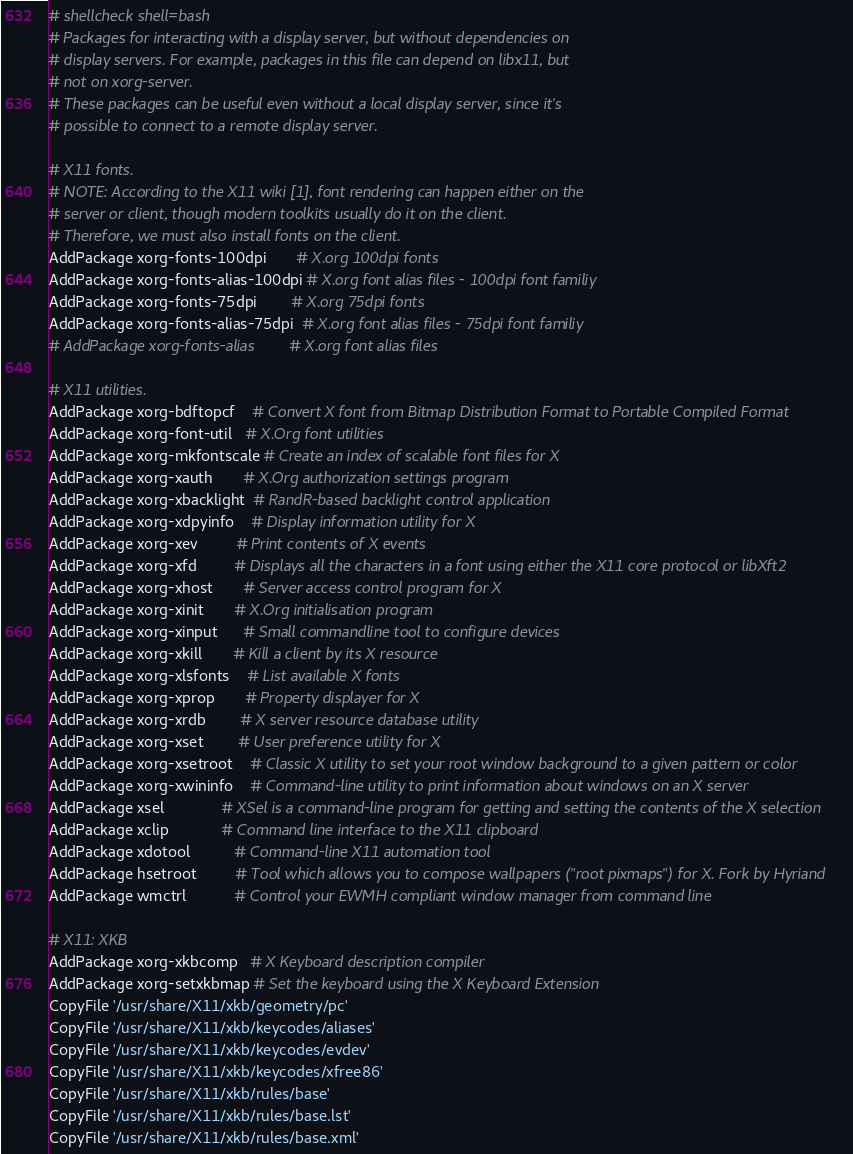Convert code to text. <code><loc_0><loc_0><loc_500><loc_500><_Bash_># shellcheck shell=bash
# Packages for interacting with a display server, but without dependencies on
# display servers. For example, packages in this file can depend on libx11, but
# not on xorg-server.
# These packages can be useful even without a local display server, since it's
# possible to connect to a remote display server.

# X11 fonts.
# NOTE: According to the X11 wiki [1], font rendering can happen either on the
# server or client, though modern toolkits usually do it on the client.
# Therefore, we must also install fonts on the client.
AddPackage xorg-fonts-100dpi       # X.org 100dpi fonts
AddPackage xorg-fonts-alias-100dpi # X.org font alias files - 100dpi font familiy
AddPackage xorg-fonts-75dpi        # X.org 75dpi fonts
AddPackage xorg-fonts-alias-75dpi  # X.org font alias files - 75dpi font familiy
# AddPackage xorg-fonts-alias        # X.org font alias files

# X11 utilities.
AddPackage xorg-bdftopcf    # Convert X font from Bitmap Distribution Format to Portable Compiled Format
AddPackage xorg-font-util   # X.Org font utilities
AddPackage xorg-mkfontscale # Create an index of scalable font files for X
AddPackage xorg-xauth       # X.Org authorization settings program
AddPackage xorg-xbacklight  # RandR-based backlight control application
AddPackage xorg-xdpyinfo    # Display information utility for X
AddPackage xorg-xev         # Print contents of X events
AddPackage xorg-xfd         # Displays all the characters in a font using either the X11 core protocol or libXft2
AddPackage xorg-xhost       # Server access control program for X
AddPackage xorg-xinit       # X.Org initialisation program
AddPackage xorg-xinput      # Small commandline tool to configure devices
AddPackage xorg-xkill       # Kill a client by its X resource
AddPackage xorg-xlsfonts    # List available X fonts
AddPackage xorg-xprop       # Property displayer for X
AddPackage xorg-xrdb        # X server resource database utility
AddPackage xorg-xset        # User preference utility for X
AddPackage xorg-xsetroot    # Classic X utility to set your root window background to a given pattern or color
AddPackage xorg-xwininfo    # Command-line utility to print information about windows on an X server
AddPackage xsel             # XSel is a command-line program for getting and setting the contents of the X selection
AddPackage xclip            # Command line interface to the X11 clipboard
AddPackage xdotool          # Command-line X11 automation tool
AddPackage hsetroot         # Tool which allows you to compose wallpapers ("root pixmaps") for X. Fork by Hyriand
AddPackage wmctrl           # Control your EWMH compliant window manager from command line

# X11: XKB
AddPackage xorg-xkbcomp   # X Keyboard description compiler
AddPackage xorg-setxkbmap # Set the keyboard using the X Keyboard Extension
CopyFile '/usr/share/X11/xkb/geometry/pc'
CopyFile '/usr/share/X11/xkb/keycodes/aliases'
CopyFile '/usr/share/X11/xkb/keycodes/evdev'
CopyFile '/usr/share/X11/xkb/keycodes/xfree86'
CopyFile '/usr/share/X11/xkb/rules/base'
CopyFile '/usr/share/X11/xkb/rules/base.lst'
CopyFile '/usr/share/X11/xkb/rules/base.xml'</code> 